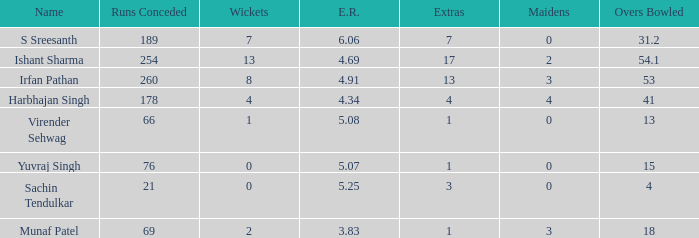Name the maaidens where overs bowled is 13 0.0. Parse the full table. {'header': ['Name', 'Runs Conceded', 'Wickets', 'E.R.', 'Extras', 'Maidens', 'Overs Bowled'], 'rows': [['S Sreesanth', '189', '7', '6.06', '7', '0', '31.2'], ['Ishant Sharma', '254', '13', '4.69', '17', '2', '54.1'], ['Irfan Pathan', '260', '8', '4.91', '13', '3', '53'], ['Harbhajan Singh', '178', '4', '4.34', '4', '4', '41'], ['Virender Sehwag', '66', '1', '5.08', '1', '0', '13'], ['Yuvraj Singh', '76', '0', '5.07', '1', '0', '15'], ['Sachin Tendulkar', '21', '0', '5.25', '3', '0', '4'], ['Munaf Patel', '69', '2', '3.83', '1', '3', '18']]} 